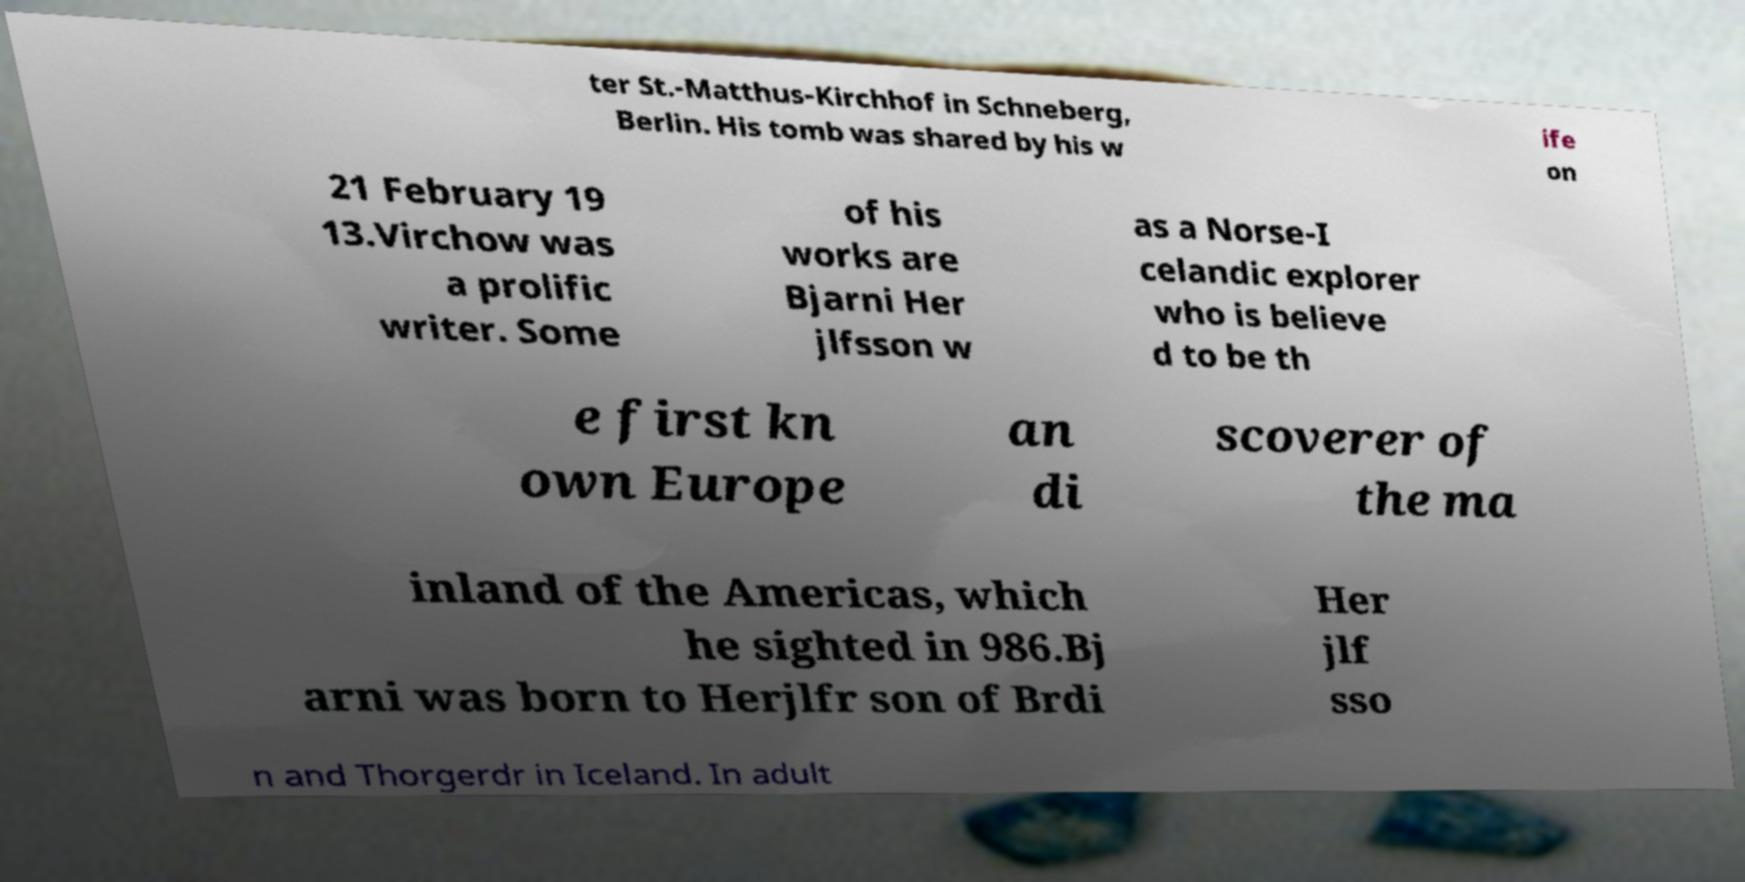Could you assist in decoding the text presented in this image and type it out clearly? ter St.-Matthus-Kirchhof in Schneberg, Berlin. His tomb was shared by his w ife on 21 February 19 13.Virchow was a prolific writer. Some of his works are Bjarni Her jlfsson w as a Norse-I celandic explorer who is believe d to be th e first kn own Europe an di scoverer of the ma inland of the Americas, which he sighted in 986.Bj arni was born to Herjlfr son of Brdi Her jlf sso n and Thorgerdr in Iceland. In adult 